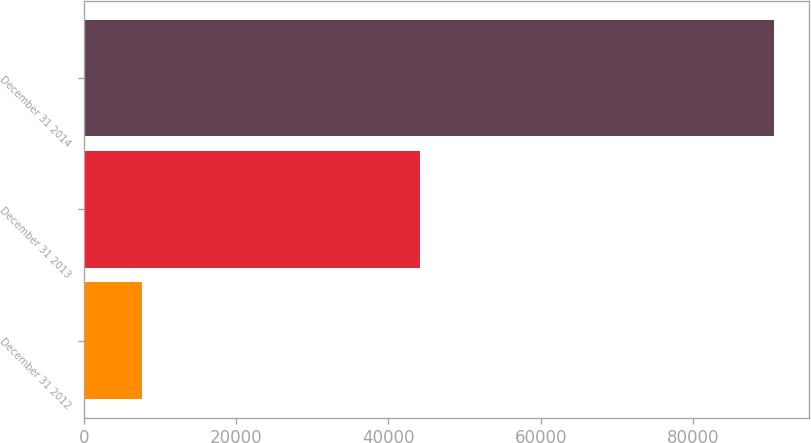<chart> <loc_0><loc_0><loc_500><loc_500><bar_chart><fcel>December 31 2012<fcel>December 31 2013<fcel>December 31 2014<nl><fcel>7604<fcel>44106<fcel>90650<nl></chart> 